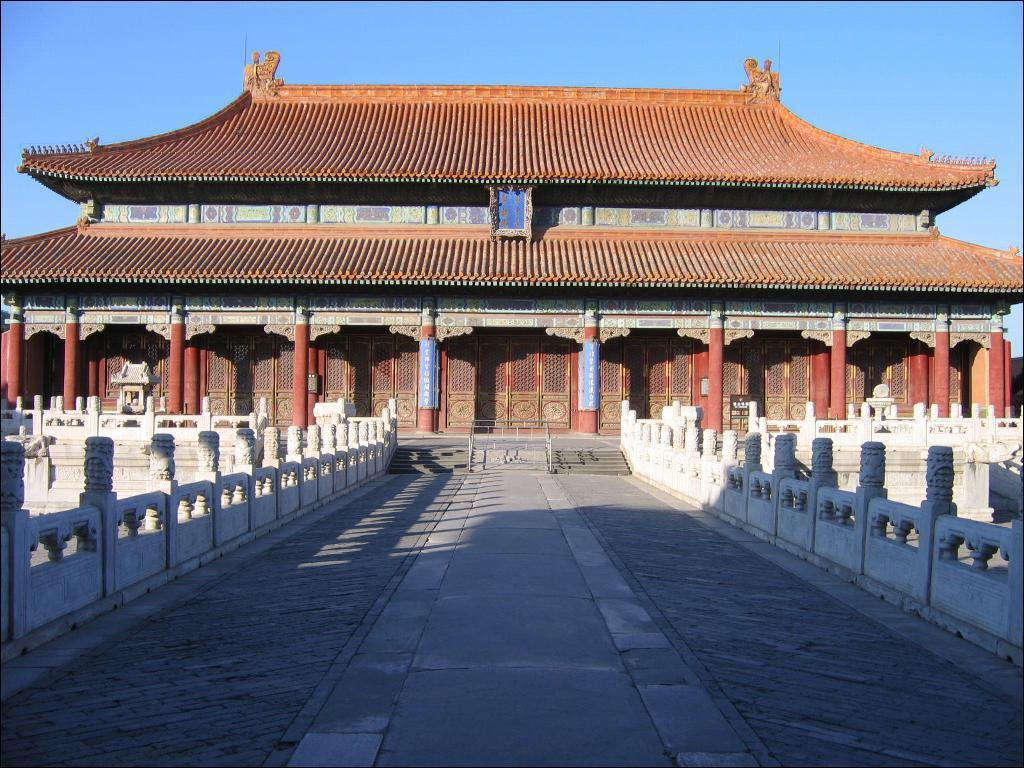What type of structure is visible in the image? There is a house in the image. What is located in front of the house? There is a bridge in front of the house. What is visible at the top of the image? The sky is visible at the top of the image. What type of cloth is draped over the queen in the image? There is no queen or cloth present in the image. 